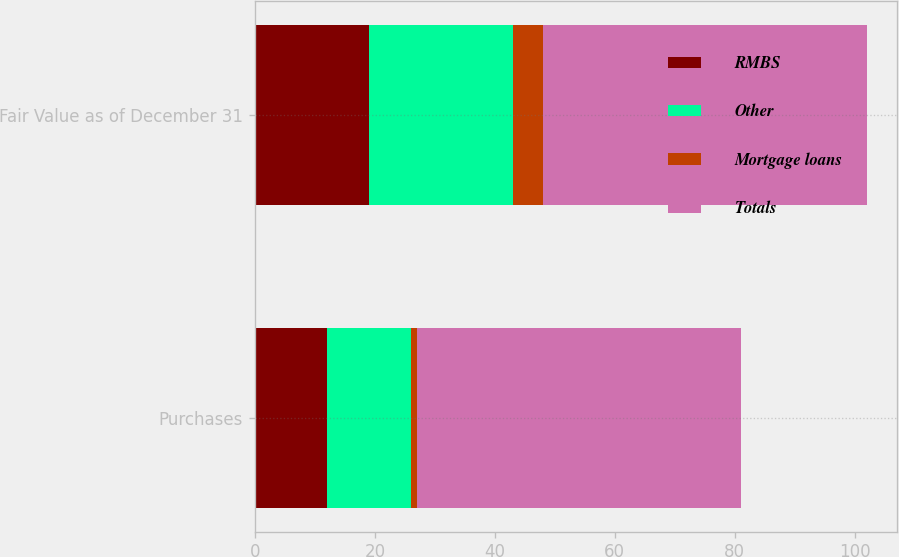<chart> <loc_0><loc_0><loc_500><loc_500><stacked_bar_chart><ecel><fcel>Purchases<fcel>Fair Value as of December 31<nl><fcel>RMBS<fcel>12<fcel>19<nl><fcel>Other<fcel>14<fcel>24<nl><fcel>Mortgage loans<fcel>1<fcel>5<nl><fcel>Totals<fcel>54<fcel>54<nl></chart> 